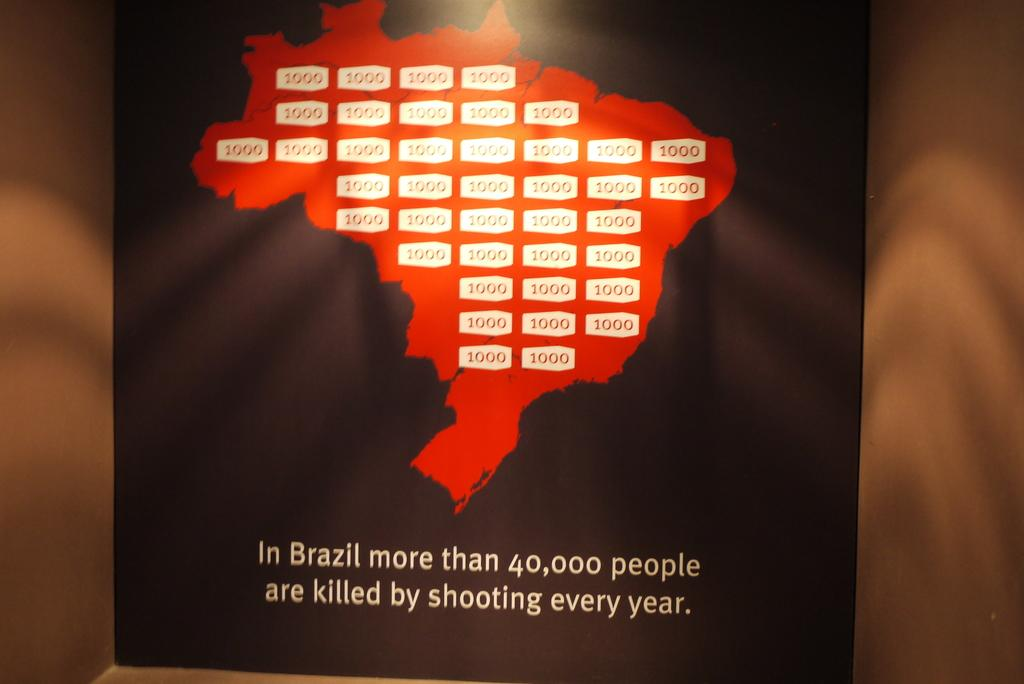<image>
Write a terse but informative summary of the picture. A poster displaying how many people in Brazil are killed in shootings each year. 